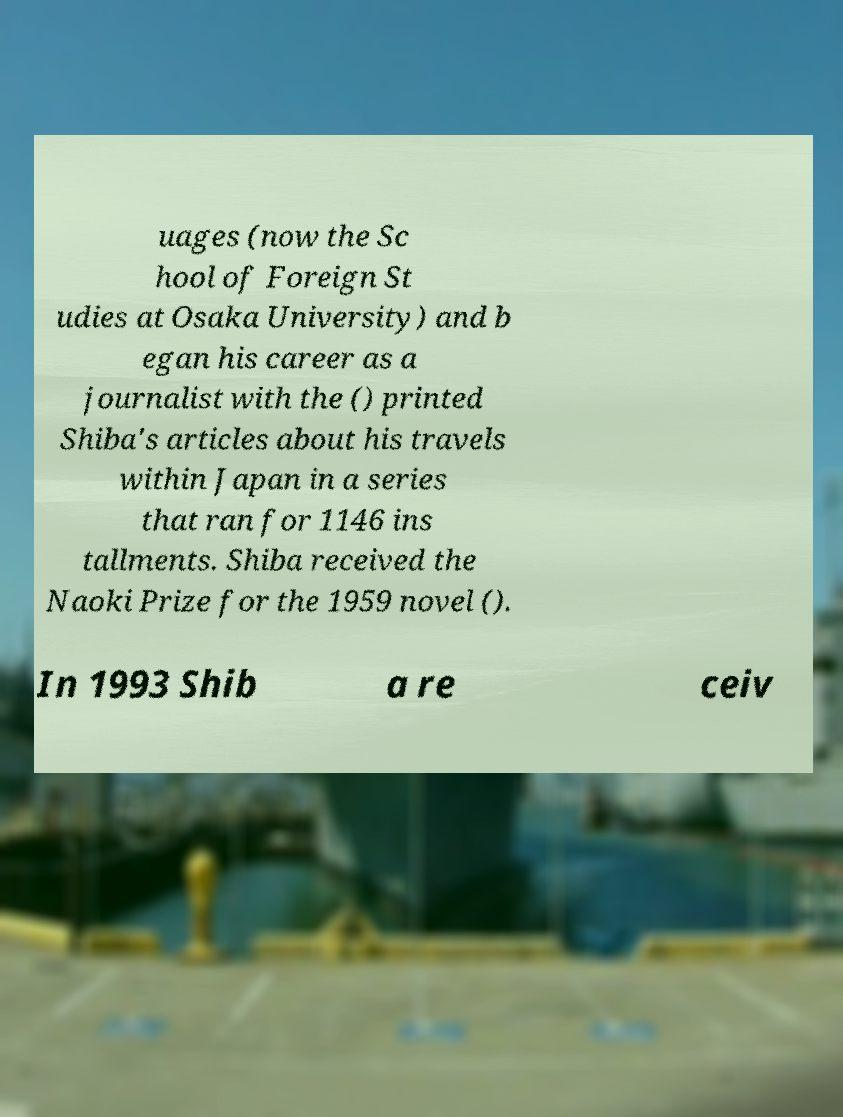Could you assist in decoding the text presented in this image and type it out clearly? uages (now the Sc hool of Foreign St udies at Osaka University) and b egan his career as a journalist with the () printed Shiba's articles about his travels within Japan in a series that ran for 1146 ins tallments. Shiba received the Naoki Prize for the 1959 novel (). In 1993 Shib a re ceiv 